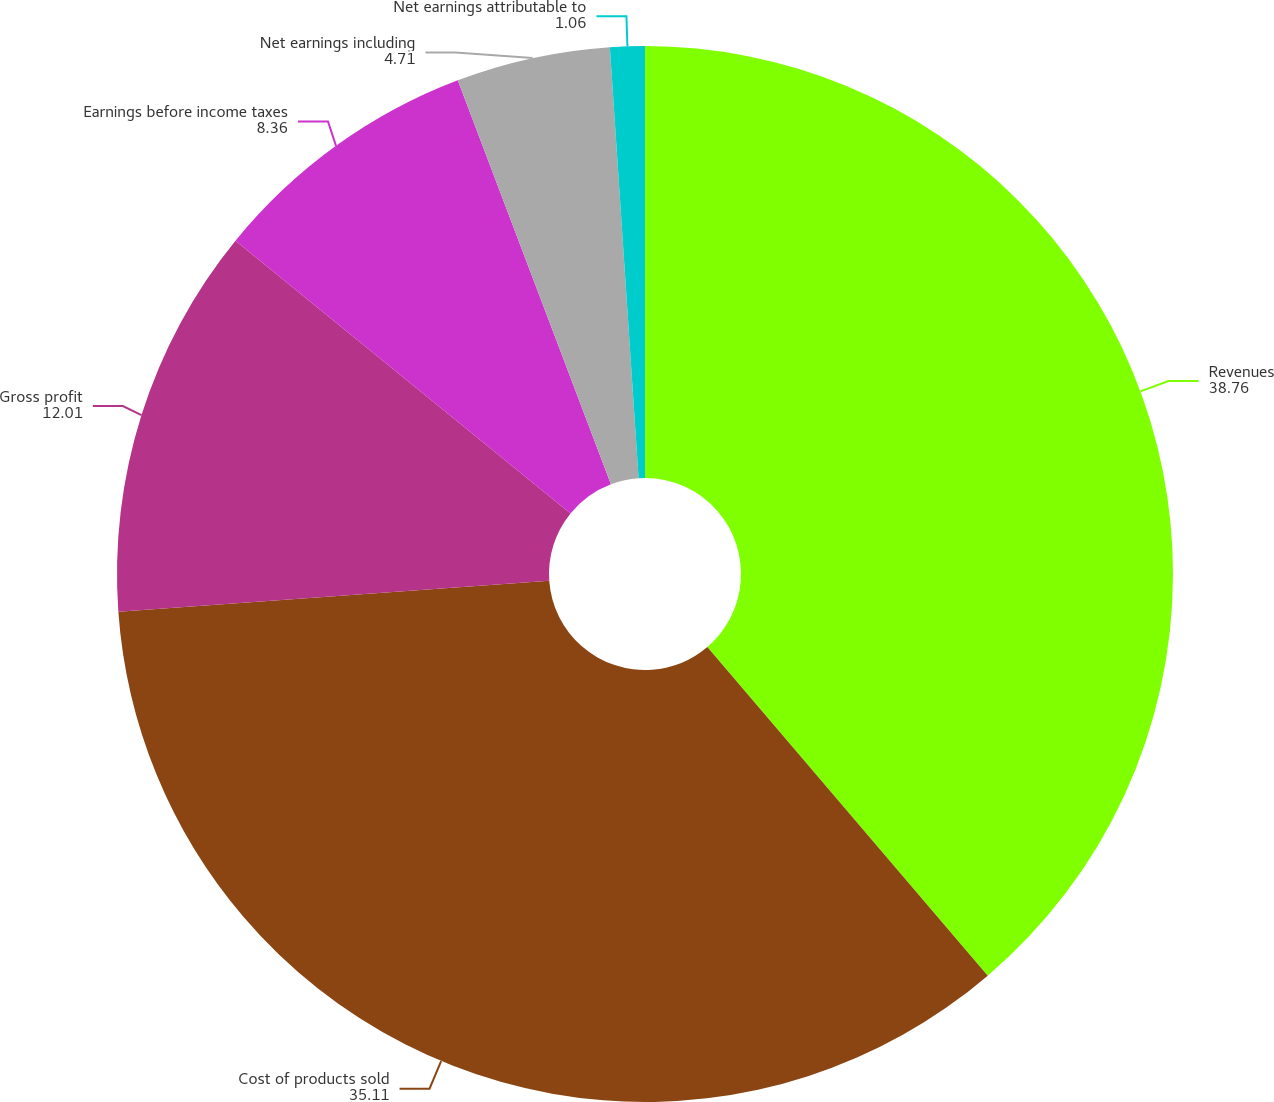Convert chart. <chart><loc_0><loc_0><loc_500><loc_500><pie_chart><fcel>Revenues<fcel>Cost of products sold<fcel>Gross profit<fcel>Earnings before income taxes<fcel>Net earnings including<fcel>Net earnings attributable to<nl><fcel>38.76%<fcel>35.11%<fcel>12.01%<fcel>8.36%<fcel>4.71%<fcel>1.06%<nl></chart> 